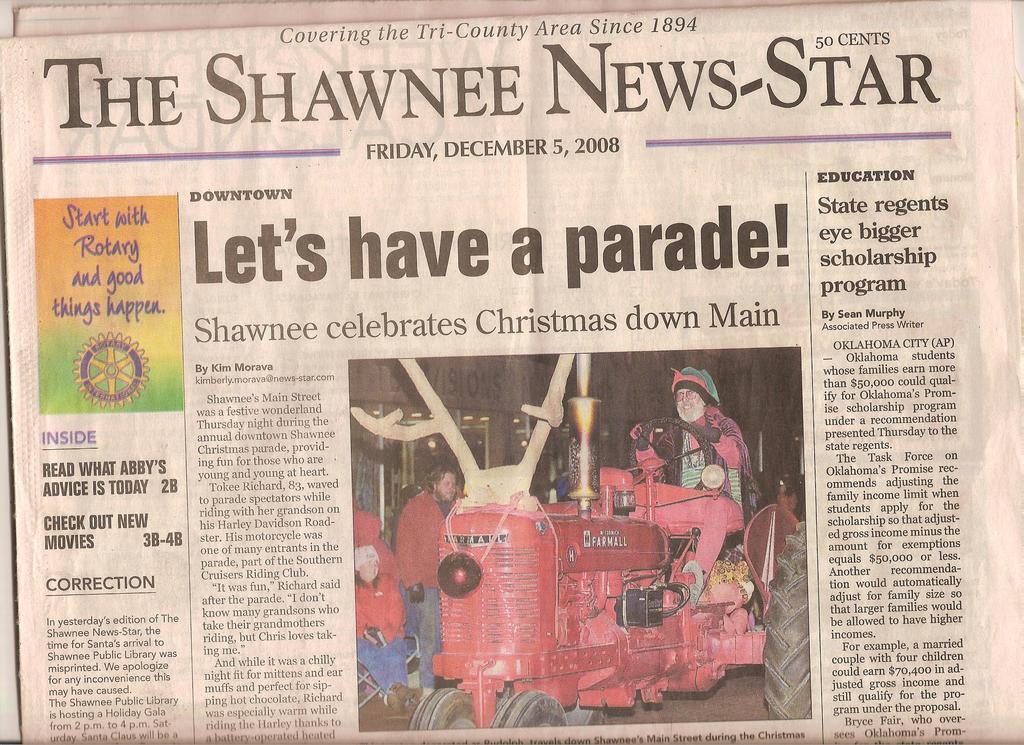How long has this paper been around?
Provide a short and direct response. 1894. 